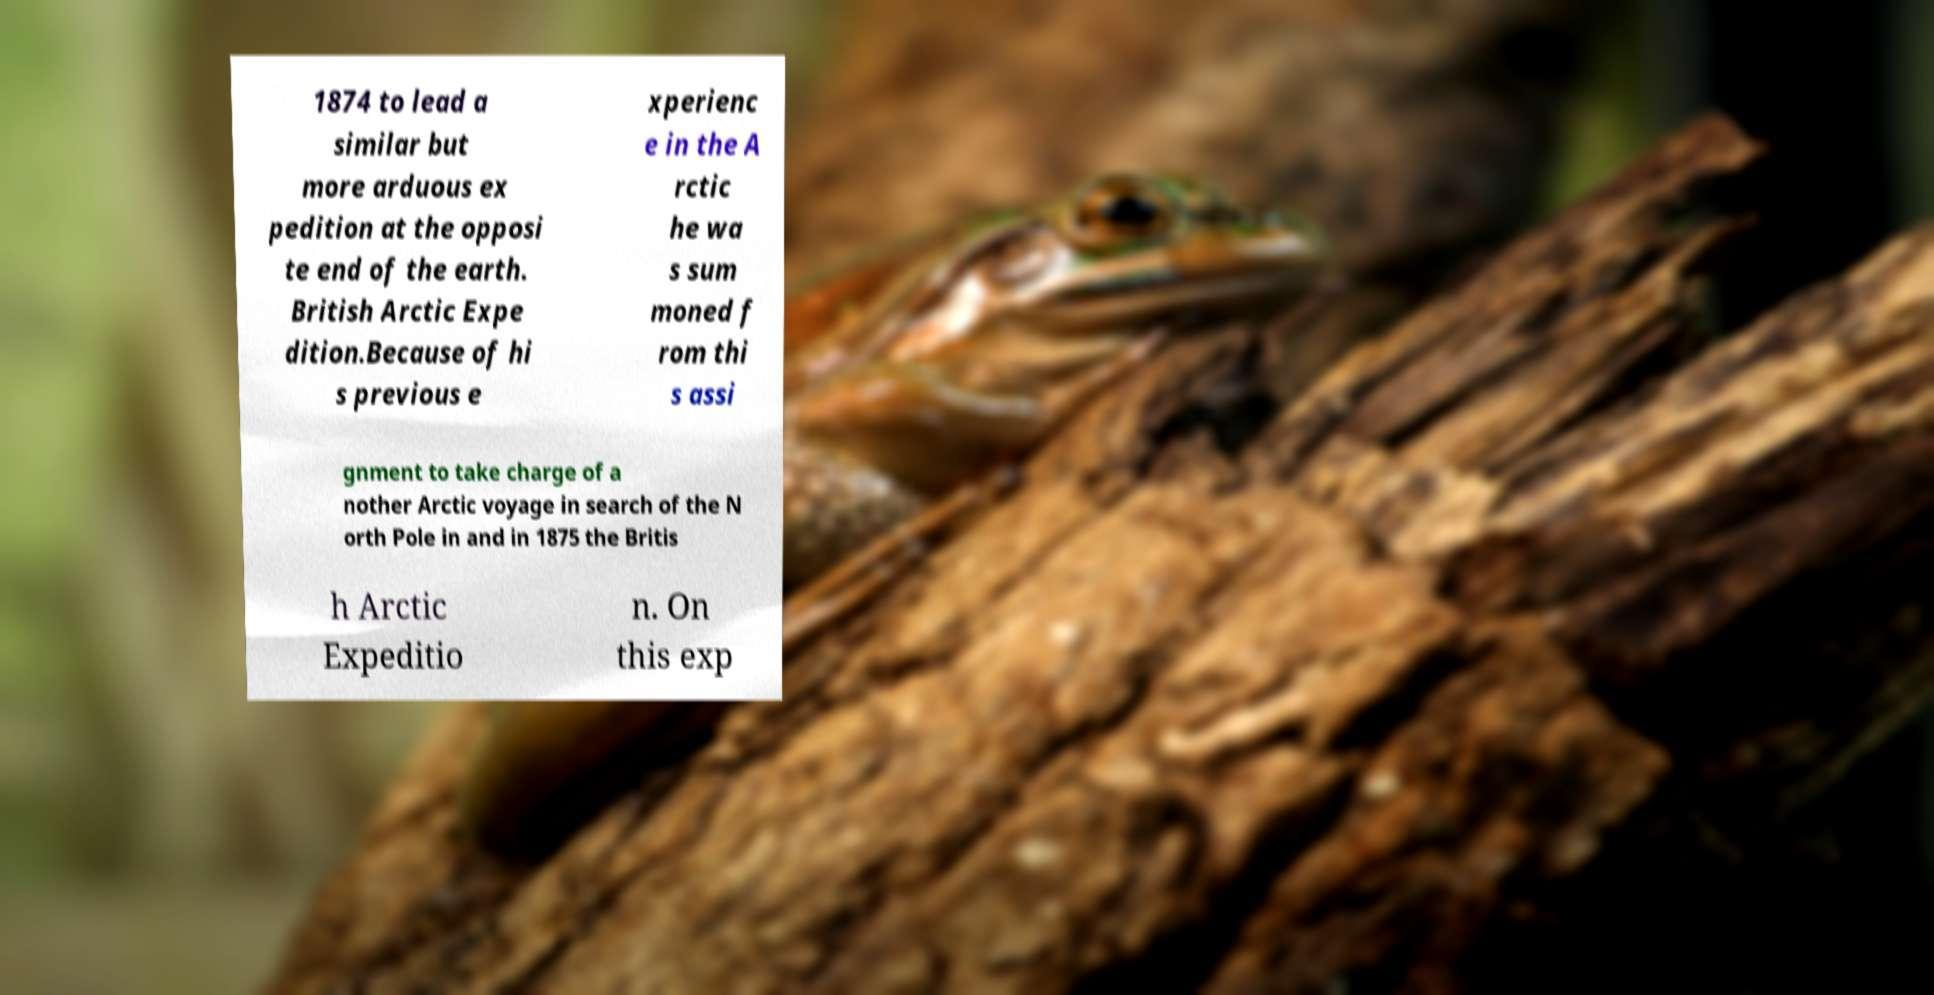Can you accurately transcribe the text from the provided image for me? 1874 to lead a similar but more arduous ex pedition at the opposi te end of the earth. British Arctic Expe dition.Because of hi s previous e xperienc e in the A rctic he wa s sum moned f rom thi s assi gnment to take charge of a nother Arctic voyage in search of the N orth Pole in and in 1875 the Britis h Arctic Expeditio n. On this exp 